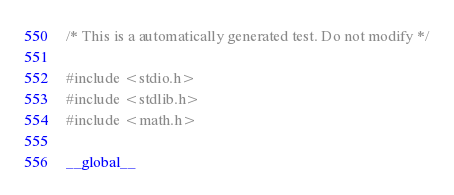Convert code to text. <code><loc_0><loc_0><loc_500><loc_500><_Cuda_>
/* This is a automatically generated test. Do not modify */

#include <stdio.h>
#include <stdlib.h>
#include <math.h>

__global__</code> 